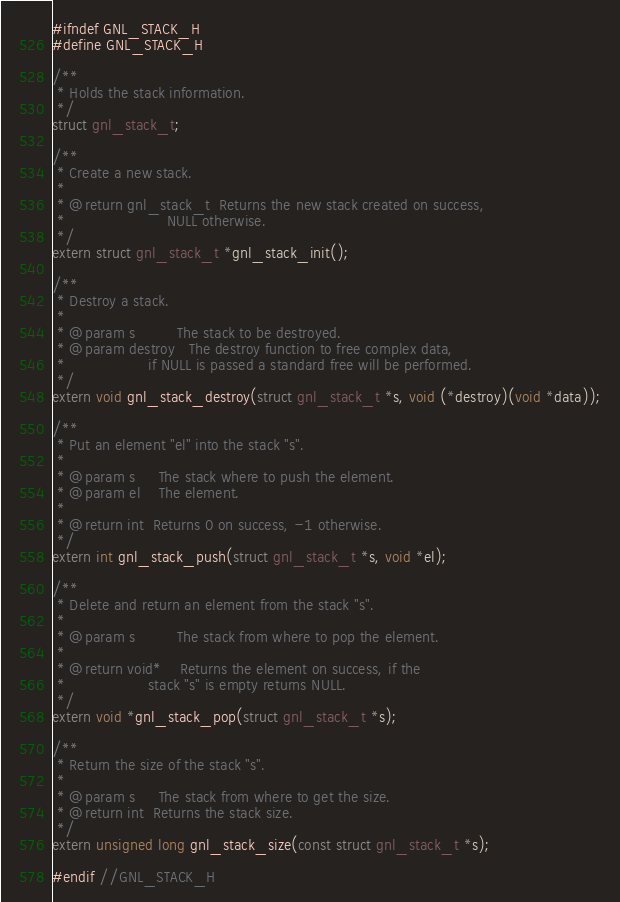Convert code to text. <code><loc_0><loc_0><loc_500><loc_500><_C_>
#ifndef GNL_STACK_H
#define GNL_STACK_H

/**
 * Holds the stack information.
 */
struct gnl_stack_t;

/**
 * Create a new stack.
 *
 * @return gnl_stack_t  Returns the new stack created on success,
 *                      NULL otherwise.
 */
extern struct gnl_stack_t *gnl_stack_init();

/**
 * Destroy a stack.
 *
 * @param s         The stack to be destroyed.
 * @param destroy   The destroy function to free complex data,
 *                  if NULL is passed a standard free will be performed.
 */
extern void gnl_stack_destroy(struct gnl_stack_t *s, void (*destroy)(void *data));

/**
 * Put an element "el" into the stack "s".
 *
 * @param s     The stack where to push the element.
 * @param el    The element.
 *
 * @return int  Returns 0 on success, -1 otherwise.
 */
extern int gnl_stack_push(struct gnl_stack_t *s, void *el);

/**
 * Delete and return an element from the stack "s".
 *
 * @param s         The stack from where to pop the element.
 *
 * @return void*    Returns the element on success, if the
 *                  stack "s" is empty returns NULL.
 */
extern void *gnl_stack_pop(struct gnl_stack_t *s);

/**
 * Return the size of the stack "s".
 *
 * @param s     The stack from where to get the size.
 * @return int  Returns the stack size.
 */
extern unsigned long gnl_stack_size(const struct gnl_stack_t *s);

#endif //GNL_STACK_H</code> 